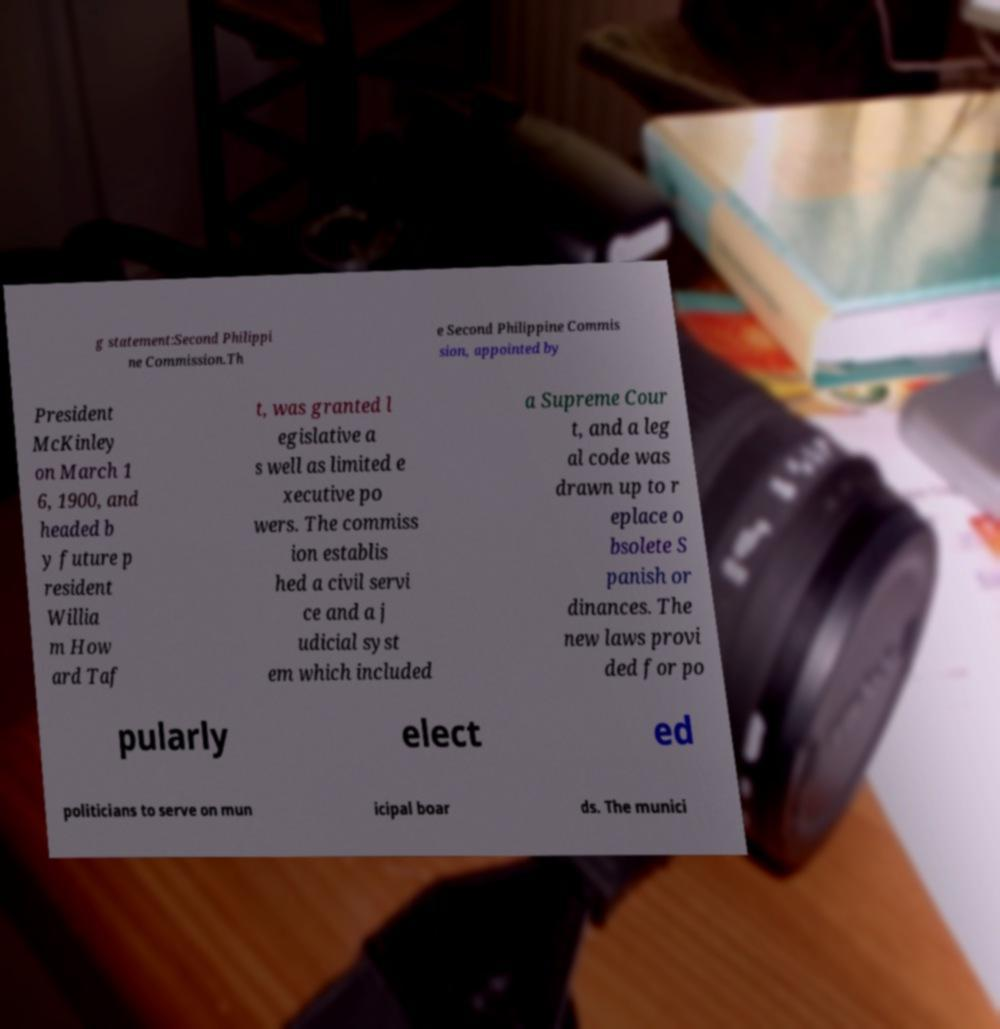Please identify and transcribe the text found in this image. g statement:Second Philippi ne Commission.Th e Second Philippine Commis sion, appointed by President McKinley on March 1 6, 1900, and headed b y future p resident Willia m How ard Taf t, was granted l egislative a s well as limited e xecutive po wers. The commiss ion establis hed a civil servi ce and a j udicial syst em which included a Supreme Cour t, and a leg al code was drawn up to r eplace o bsolete S panish or dinances. The new laws provi ded for po pularly elect ed politicians to serve on mun icipal boar ds. The munici 